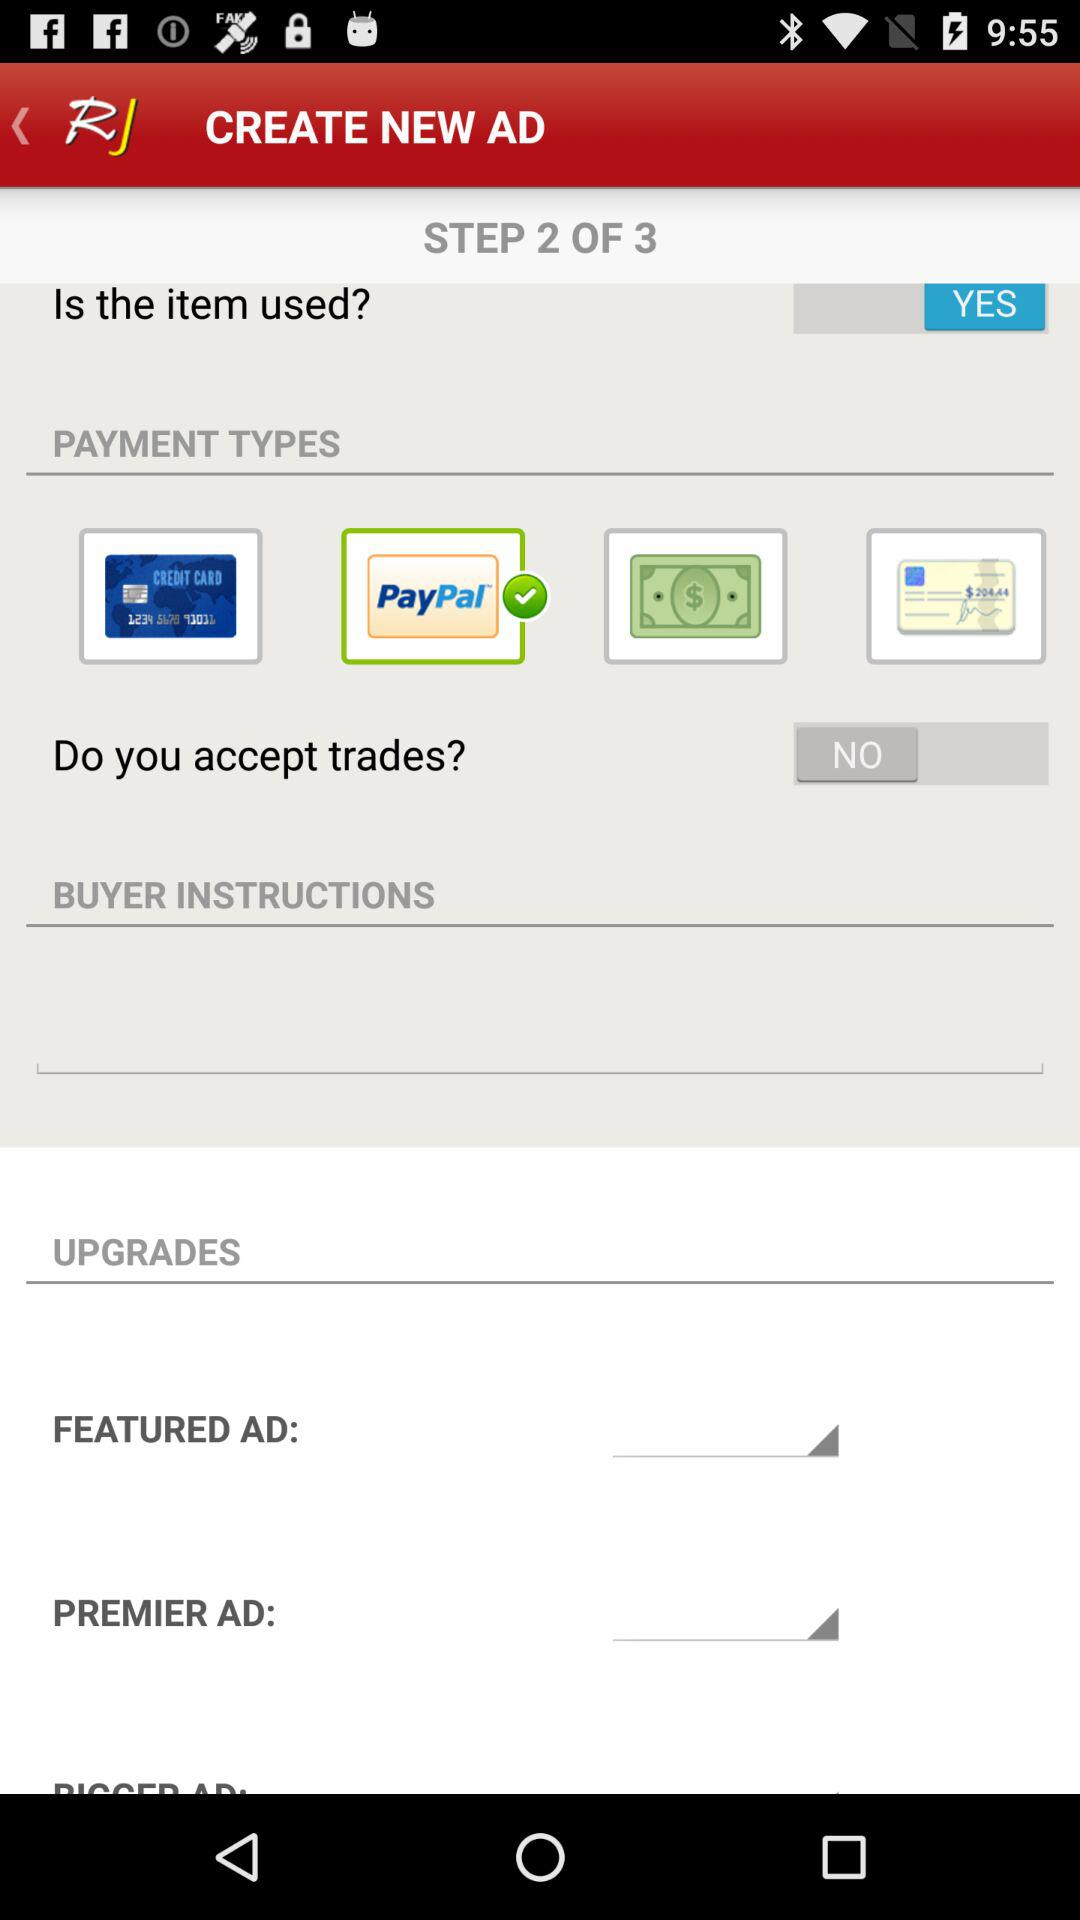At which step are we right now? You are right now at the second step. 